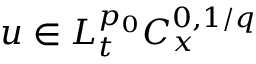Convert formula to latex. <formula><loc_0><loc_0><loc_500><loc_500>u \in L _ { t } ^ { p _ { 0 } } C _ { x } ^ { 0 , 1 / q }</formula> 